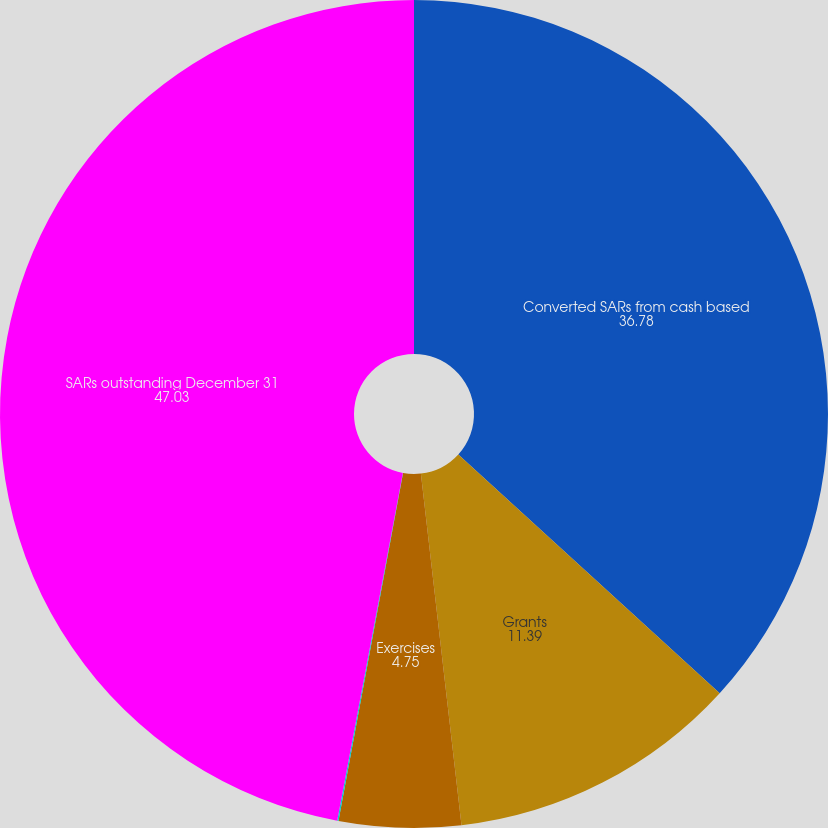<chart> <loc_0><loc_0><loc_500><loc_500><pie_chart><fcel>Converted SARs from cash based<fcel>Grants<fcel>Exercises<fcel>Forfeitures and adjustments<fcel>SARs outstanding December 31<nl><fcel>36.78%<fcel>11.39%<fcel>4.75%<fcel>0.05%<fcel>47.03%<nl></chart> 